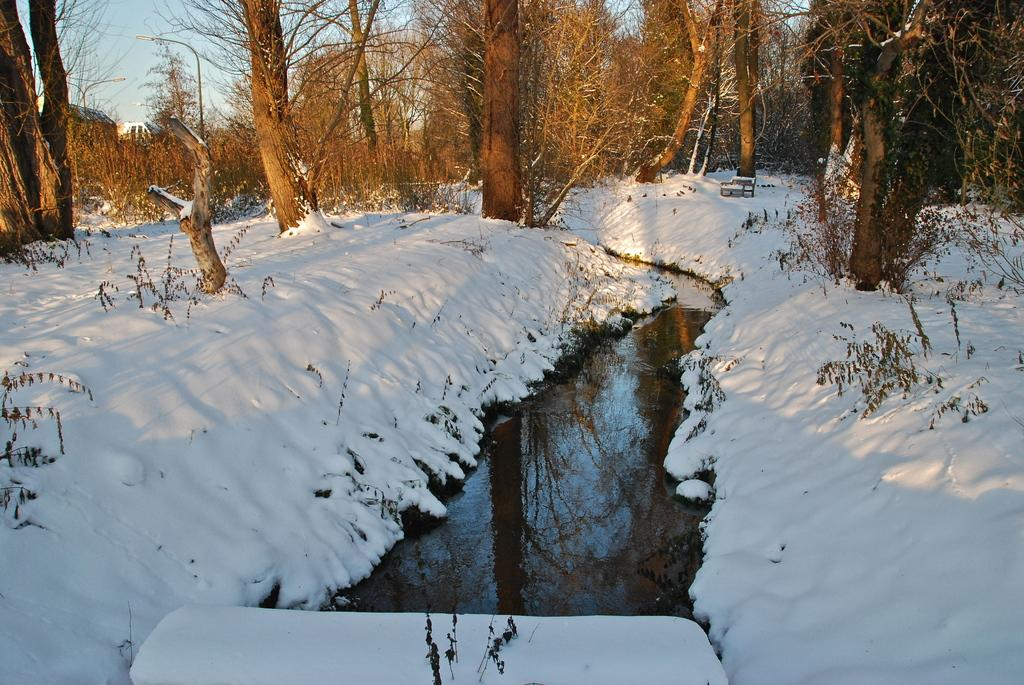What type of weather condition is depicted in the image? There is snow in the image, indicating a winter scene. What else can be seen in the image besides snow? There is water, plants, trees, and streetlights visible in the image. What is the background of the image? The sky is visible in the background of the image. What type of quince is being recorded in the image? There is no quince or record in the image. 